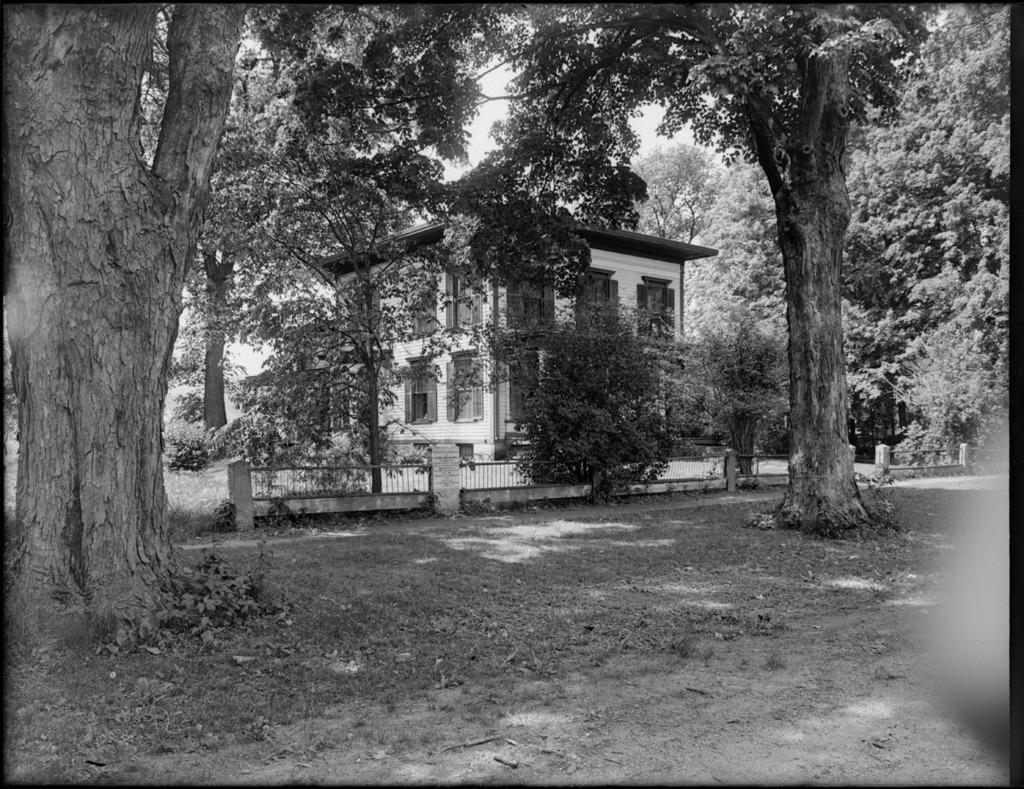Can you describe this image briefly? In this image we can see some trees walkway and in the background of the image there is fencing, house and top of the image there is clear sky. 